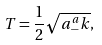Convert formula to latex. <formula><loc_0><loc_0><loc_500><loc_500>T = \frac { 1 } { 2 } \sqrt { a ^ { a } _ { - } k } ,</formula> 